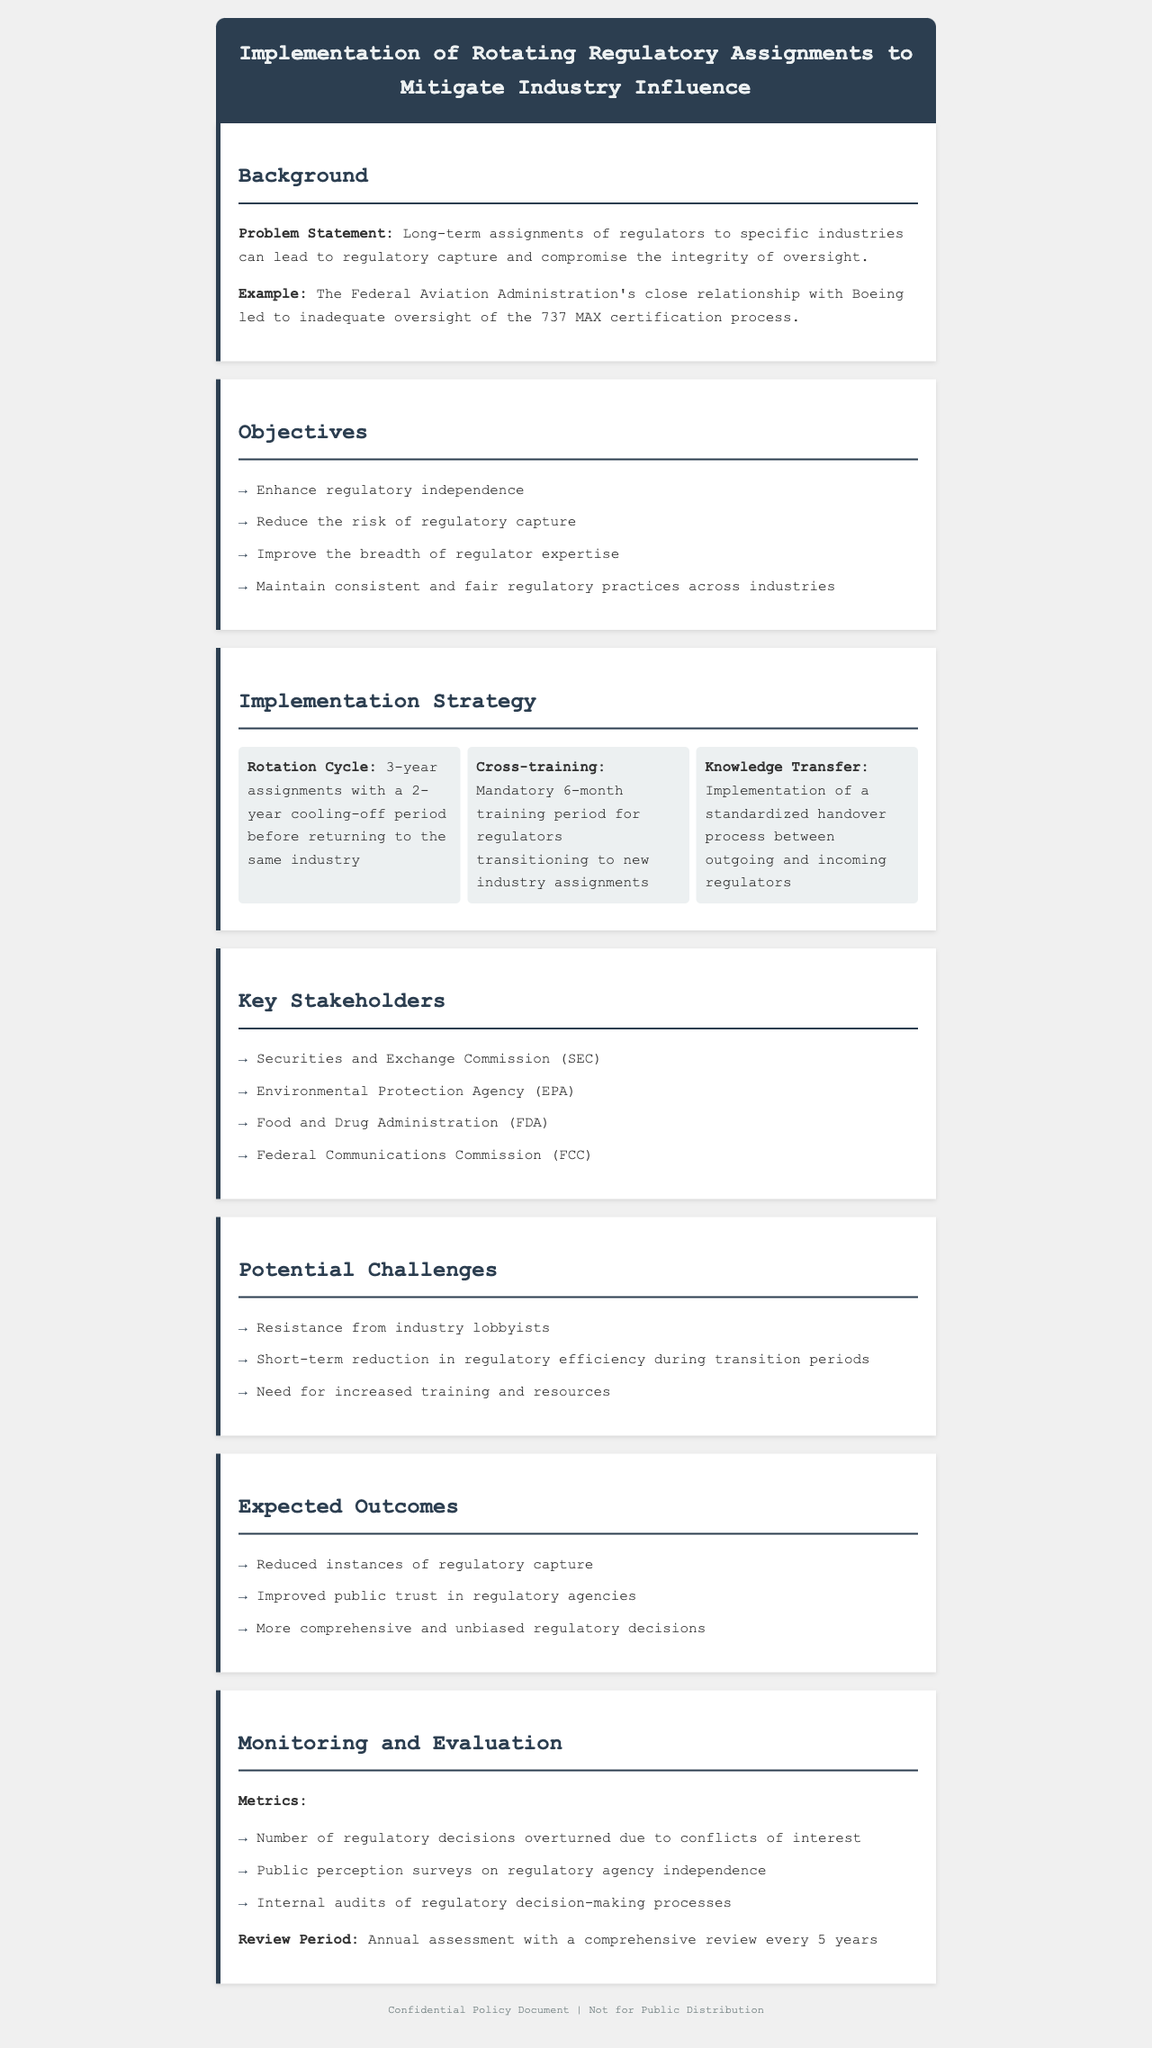what is the rotation cycle for regulatory assignments? The rotation cycle specifies the duration of assignments for regulators, which is defined in the document.
Answer: 3-year assignments how long is the cooling-off period before returning to the same industry? The cooling-off period is mentioned as part of the rotation strategy in the document.
Answer: 2-year cooling-off period what is a key objective of this policy? A specific goal is highlighted to enhance regulatory independence as part of the document's objectives.
Answer: Enhance regulatory independence which agency is listed as a key stakeholder? One of the agencies involved in this policy is provided in the document under the key stakeholders section.
Answer: Securities and Exchange Commission (SEC) what is a potential challenge mentioned in the document? A challenge related to implementation is specified, providing insight into issues that might arise.
Answer: Resistance from industry lobbyists what type of training is required for transitioning regulators? The document specifies the nature of training required for regulators moving to new assignments.
Answer: Mandatory 6-month training how will the effectiveness of the policy be monitored? Metrics for evaluating the success of the policy are outlined in the monitoring and evaluation section.
Answer: Internal audits of regulatory decision-making processes what is one expected outcome of implementing this policy? One of the anticipated effects of this policy is highlighted in the expected outcomes section of the document.
Answer: Reduced instances of regulatory capture when is the review period for the policy's assessment? The frequency of assessments is stated in the monitoring and evaluation section.
Answer: Annual assessment with a comprehensive review every 5 years 